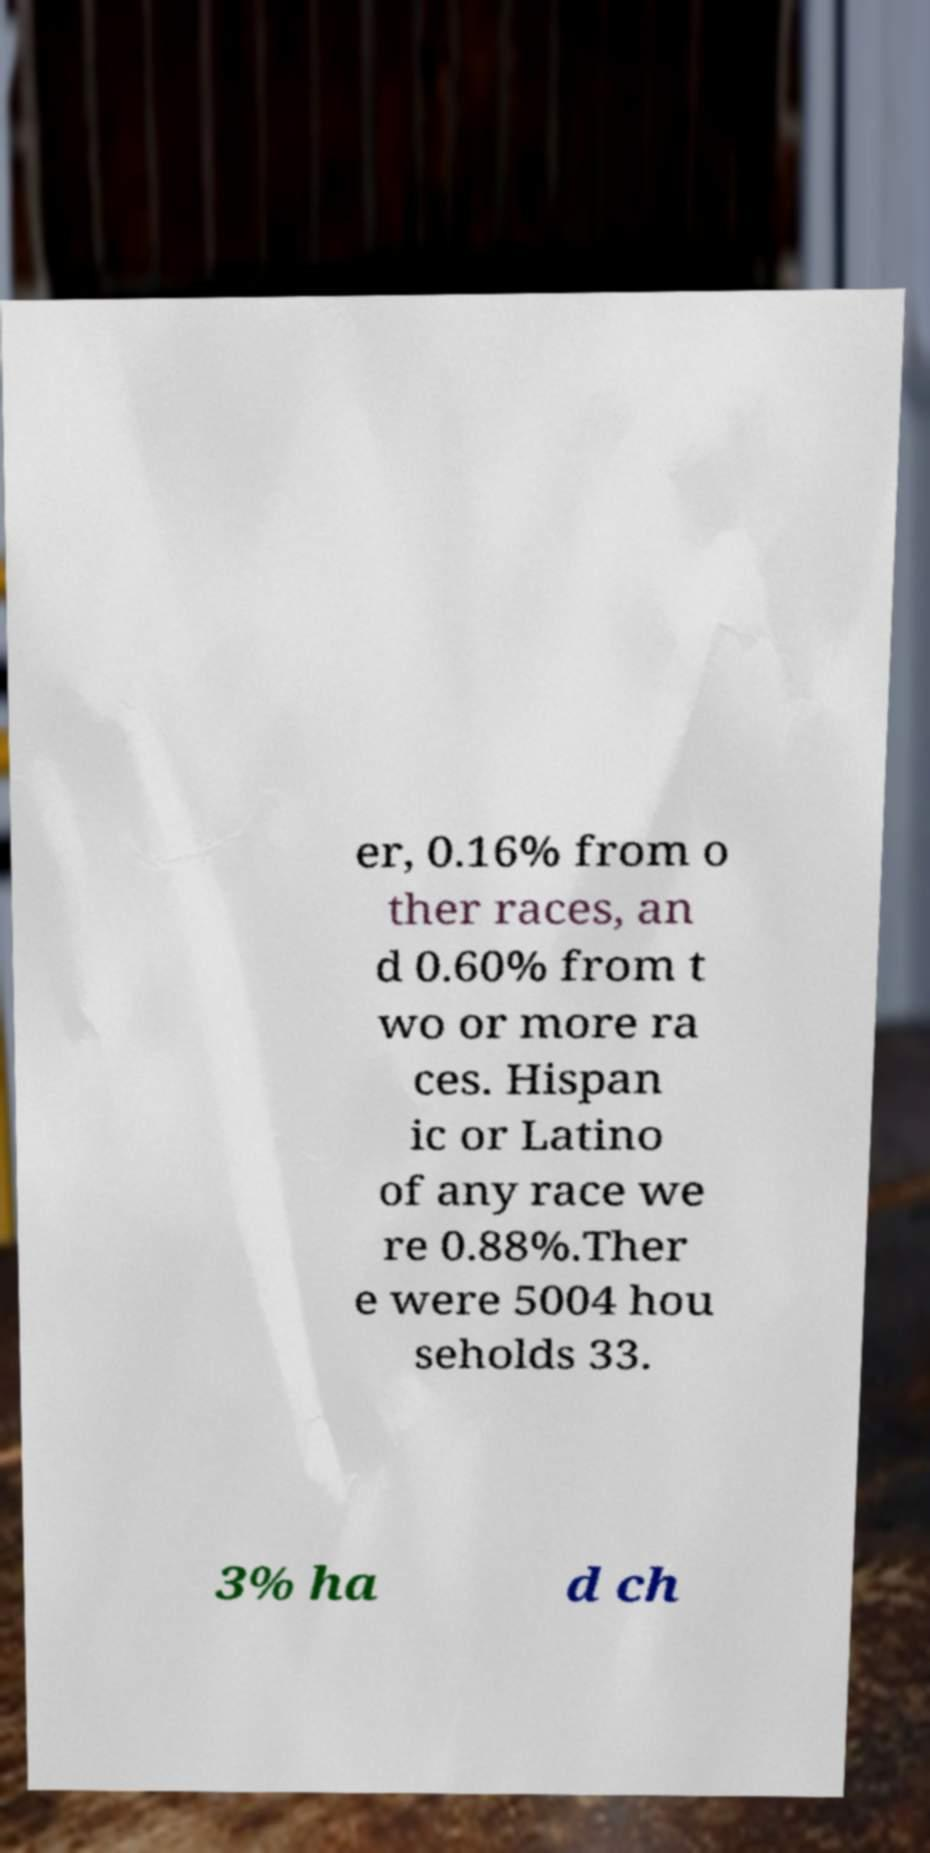There's text embedded in this image that I need extracted. Can you transcribe it verbatim? er, 0.16% from o ther races, an d 0.60% from t wo or more ra ces. Hispan ic or Latino of any race we re 0.88%.Ther e were 5004 hou seholds 33. 3% ha d ch 